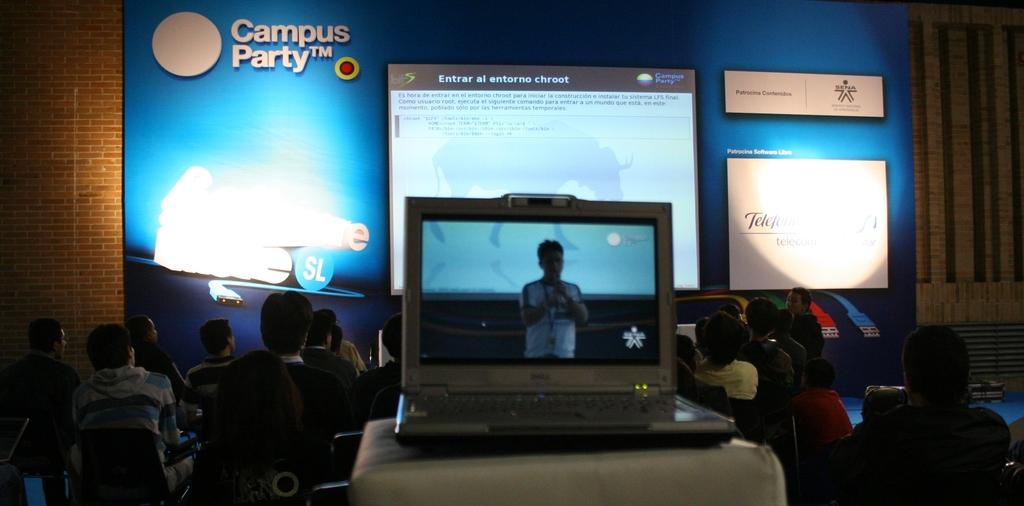Provide a one-sentence caption for the provided image. A laptop sits recording a presentation at the Campus Party conference. 